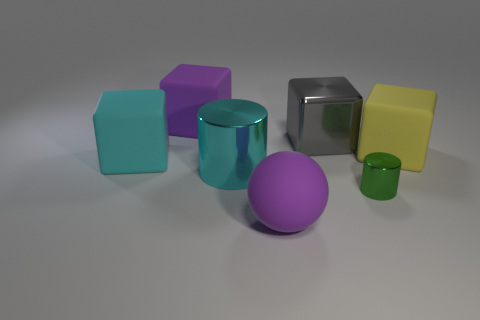Subtract all shiny cubes. How many cubes are left? 3 Subtract 1 cubes. How many cubes are left? 3 Subtract all purple cubes. How many cubes are left? 3 Add 3 cyan rubber objects. How many objects exist? 10 Subtract all blue cubes. Subtract all yellow spheres. How many cubes are left? 4 Add 3 purple balls. How many purple balls are left? 4 Add 6 big brown metallic cubes. How many big brown metallic cubes exist? 6 Subtract 0 brown cylinders. How many objects are left? 7 Subtract all blocks. How many objects are left? 3 Subtract all large cyan things. Subtract all large purple matte cubes. How many objects are left? 4 